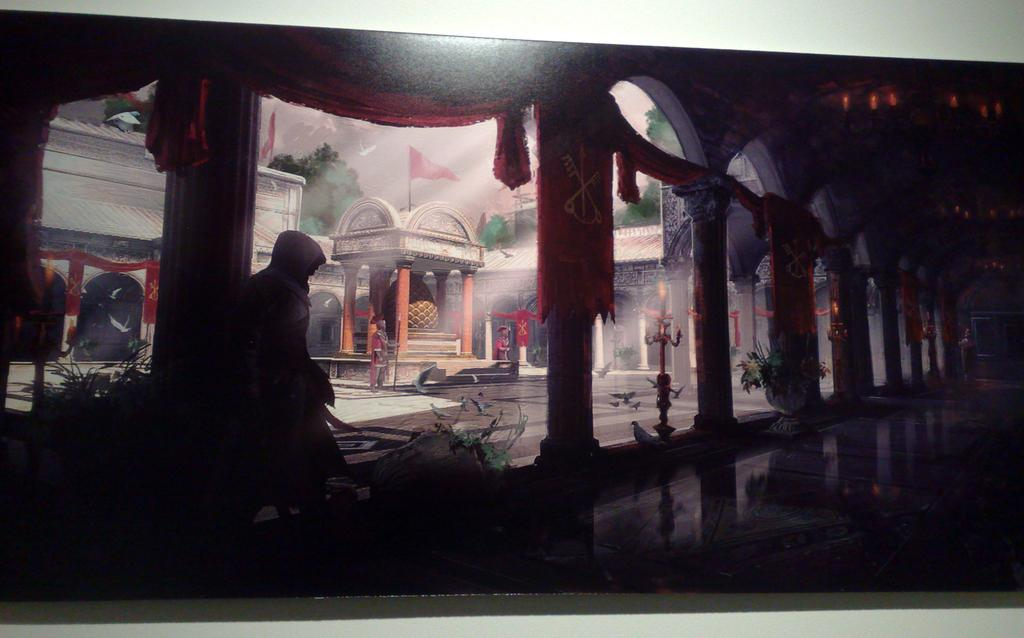What type of structures can be seen in the image? There are statues, pillars, and buildings in the image. What type of vegetation is present in the image? There are plants and trees in the image. What can be seen flying in the image? There are flags in the image. What is visible in the sky in the image? The sky is visible in the image. Is there a person present in the image? Yes, there is a person in the image. Can you hear the sound of thunder in the image? There is no sound present in the image, so it is not possible to hear thunder. Is there an ocean visible in the image? There is no ocean present in the image. What type of sign can be seen in the image? There is no sign present in the image. 